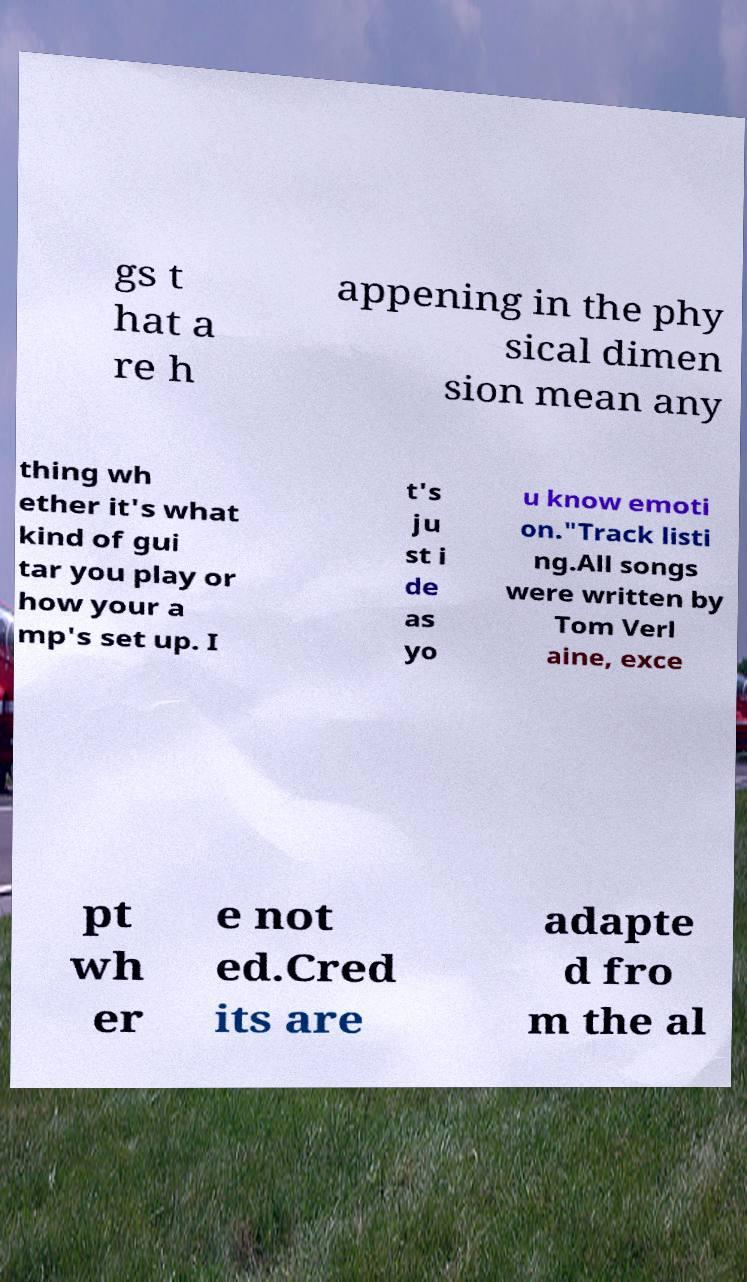Could you assist in decoding the text presented in this image and type it out clearly? gs t hat a re h appening in the phy sical dimen sion mean any thing wh ether it's what kind of gui tar you play or how your a mp's set up. I t's ju st i de as yo u know emoti on."Track listi ng.All songs were written by Tom Verl aine, exce pt wh er e not ed.Cred its are adapte d fro m the al 